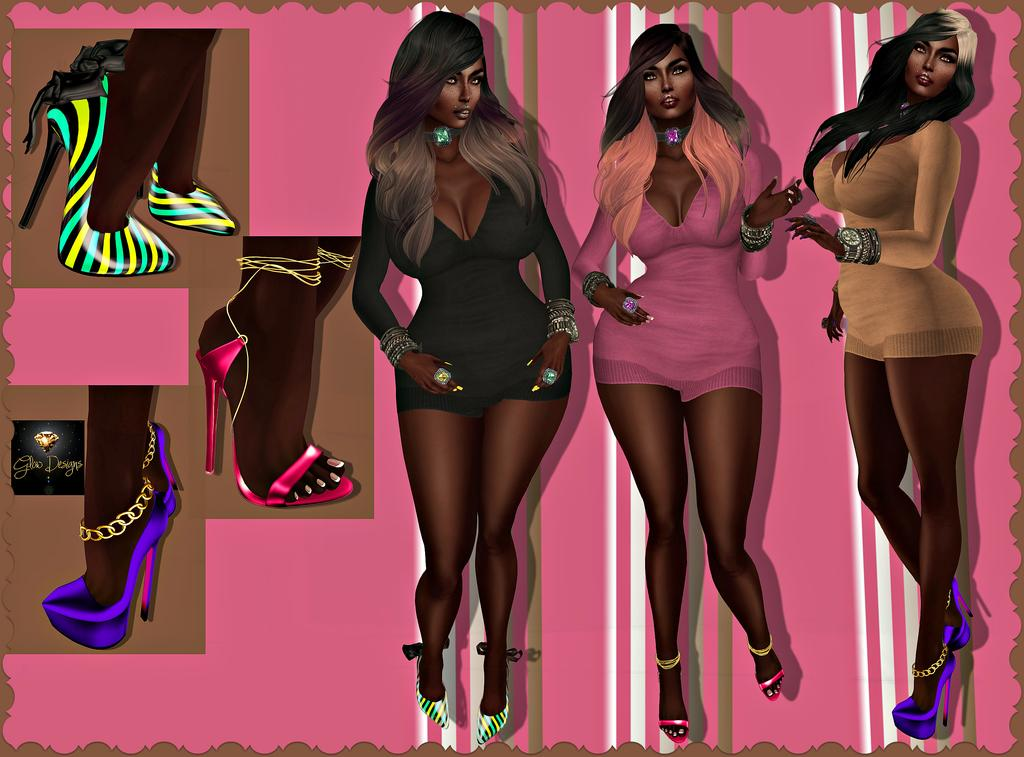What is the main subject of the image? There is a depiction of women in the image. What type of clothing can be seen in the image? Clothes are visible in the image. What type of footwear is present in the image? Sandals are present in the image. What color is the background of the image? The background of the image has a pink color. What type of stone can be seen in the image? There is no stone present in the image. What activity are the women engaged in on the boat in the image? There is no boat or activity present in the image; it features a depiction of women with clothes and sandals against a pink background. 